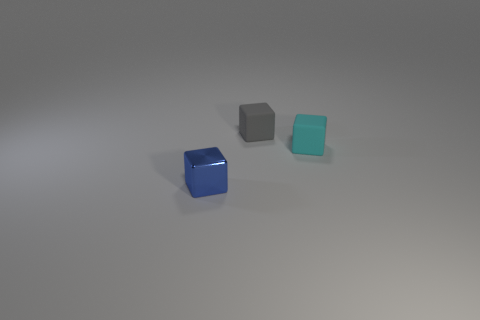Add 2 big blue matte things. How many objects exist? 5 Subtract all tiny metal objects. Subtract all small cyan objects. How many objects are left? 1 Add 2 small rubber cubes. How many small rubber cubes are left? 4 Add 2 small blue objects. How many small blue objects exist? 3 Subtract 0 red cubes. How many objects are left? 3 